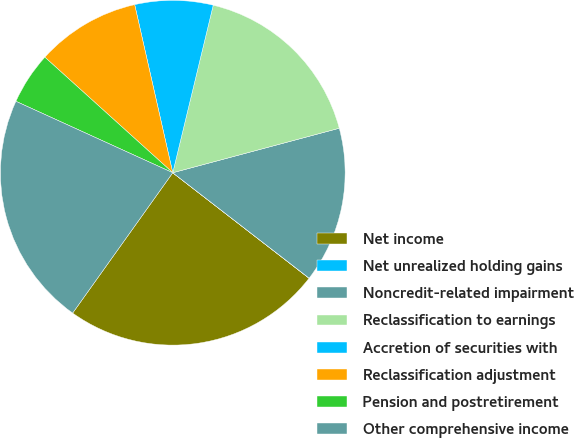Convert chart. <chart><loc_0><loc_0><loc_500><loc_500><pie_chart><fcel>Net income<fcel>Net unrealized holding gains<fcel>Noncredit-related impairment<fcel>Reclassification to earnings<fcel>Accretion of securities with<fcel>Reclassification adjustment<fcel>Pension and postretirement<fcel>Other comprehensive income<nl><fcel>24.38%<fcel>0.01%<fcel>14.63%<fcel>17.07%<fcel>7.32%<fcel>9.76%<fcel>4.89%<fcel>21.94%<nl></chart> 